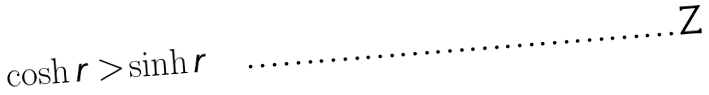Convert formula to latex. <formula><loc_0><loc_0><loc_500><loc_500>\cosh r > \sinh r</formula> 